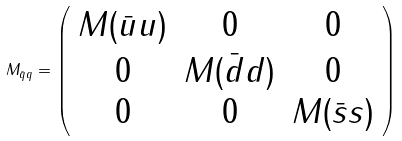<formula> <loc_0><loc_0><loc_500><loc_500>M _ { \bar { q } q } = \left ( \begin{array} { c c c } M ( \bar { u } u ) & 0 & 0 \\ 0 & M ( \bar { d } d ) & 0 \\ 0 & 0 & M ( \bar { s } s ) \end{array} \right ) \,</formula> 